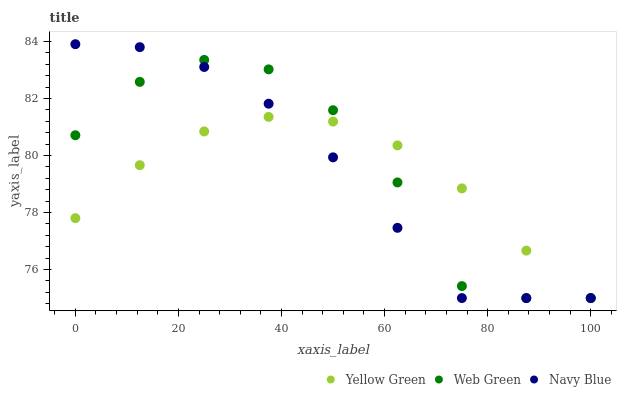Does Yellow Green have the minimum area under the curve?
Answer yes or no. Yes. Does Web Green have the maximum area under the curve?
Answer yes or no. Yes. Does Web Green have the minimum area under the curve?
Answer yes or no. No. Does Yellow Green have the maximum area under the curve?
Answer yes or no. No. Is Yellow Green the smoothest?
Answer yes or no. Yes. Is Web Green the roughest?
Answer yes or no. Yes. Is Web Green the smoothest?
Answer yes or no. No. Is Yellow Green the roughest?
Answer yes or no. No. Does Navy Blue have the lowest value?
Answer yes or no. Yes. Does Navy Blue have the highest value?
Answer yes or no. Yes. Does Web Green have the highest value?
Answer yes or no. No. Does Navy Blue intersect Yellow Green?
Answer yes or no. Yes. Is Navy Blue less than Yellow Green?
Answer yes or no. No. Is Navy Blue greater than Yellow Green?
Answer yes or no. No. 